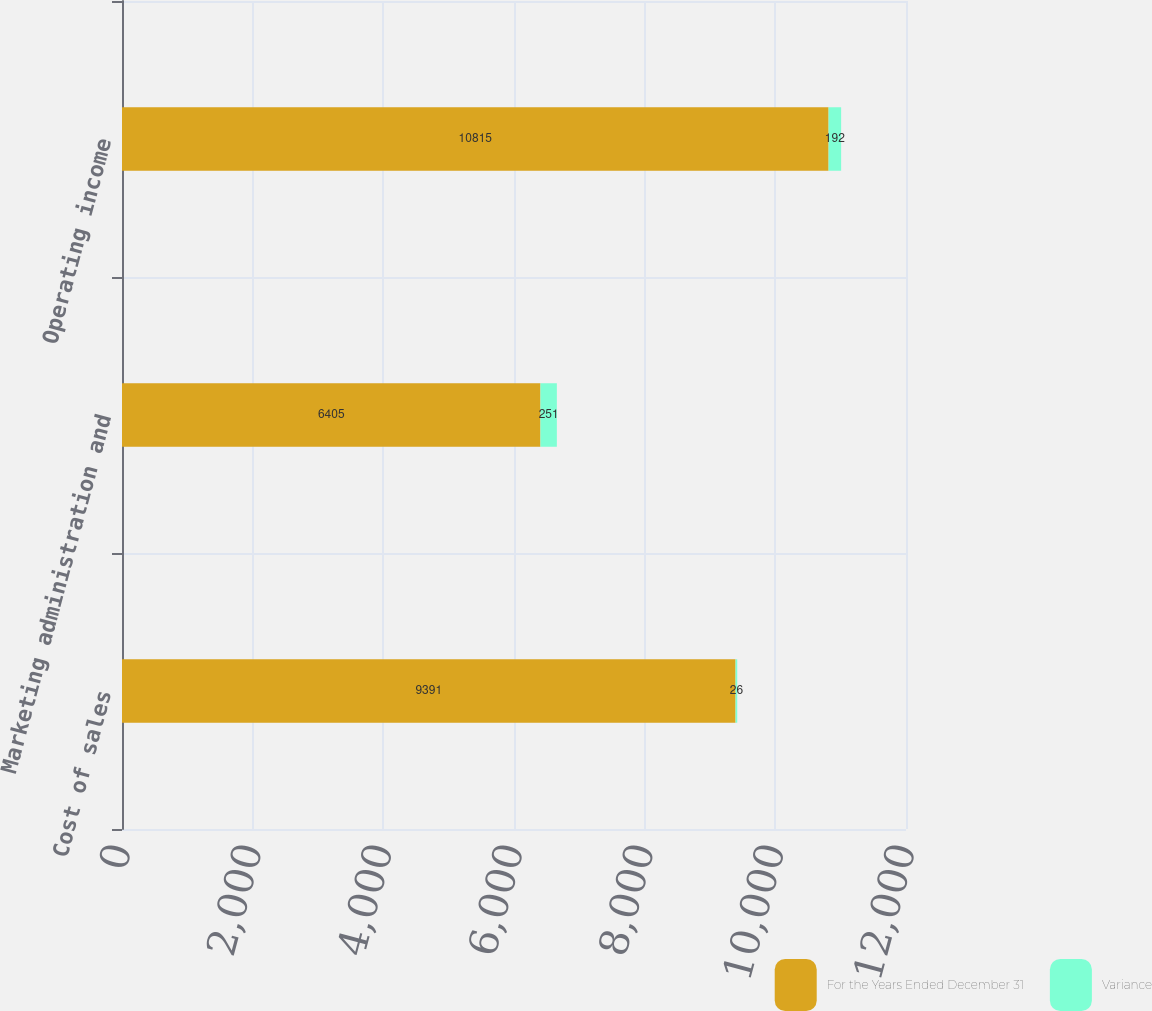Convert chart to OTSL. <chart><loc_0><loc_0><loc_500><loc_500><stacked_bar_chart><ecel><fcel>Cost of sales<fcel>Marketing administration and<fcel>Operating income<nl><fcel>For the Years Ended December 31<fcel>9391<fcel>6405<fcel>10815<nl><fcel>Variance<fcel>26<fcel>251<fcel>192<nl></chart> 